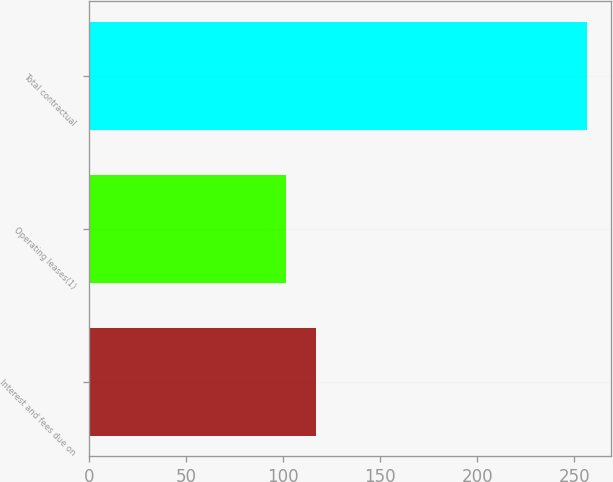Convert chart to OTSL. <chart><loc_0><loc_0><loc_500><loc_500><bar_chart><fcel>Interest and fees due on<fcel>Operating leases(1)<fcel>Total contractual<nl><fcel>117.07<fcel>101.6<fcel>256.3<nl></chart> 